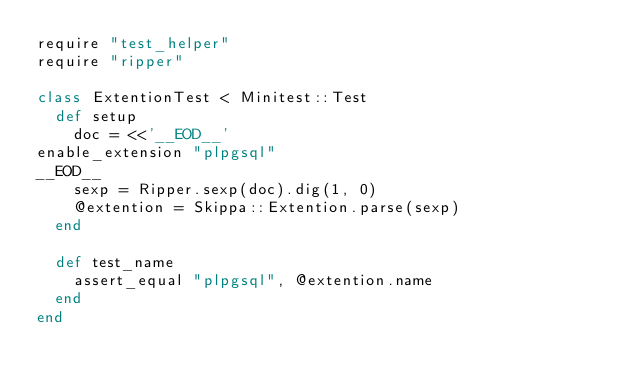<code> <loc_0><loc_0><loc_500><loc_500><_Ruby_>require "test_helper"
require "ripper"

class ExtentionTest < Minitest::Test
  def setup
    doc = <<'__EOD__'
enable_extension "plpgsql"
__EOD__
    sexp = Ripper.sexp(doc).dig(1, 0)
    @extention = Skippa::Extention.parse(sexp)
  end

  def test_name
    assert_equal "plpgsql", @extention.name
  end
end
</code> 